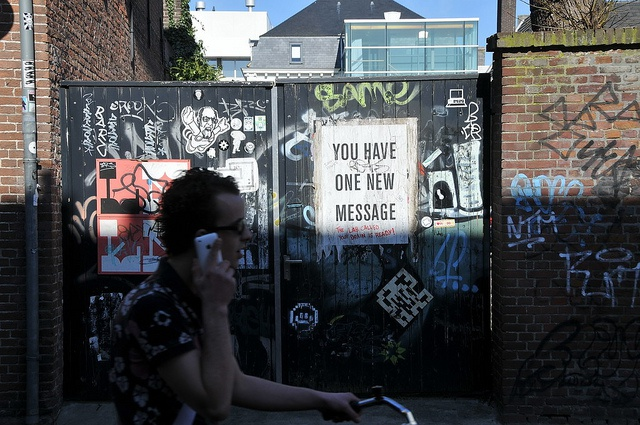Describe the objects in this image and their specific colors. I can see people in black, gray, and darkblue tones, bicycle in black, gray, and navy tones, and cell phone in black, darkblue, gray, and navy tones in this image. 